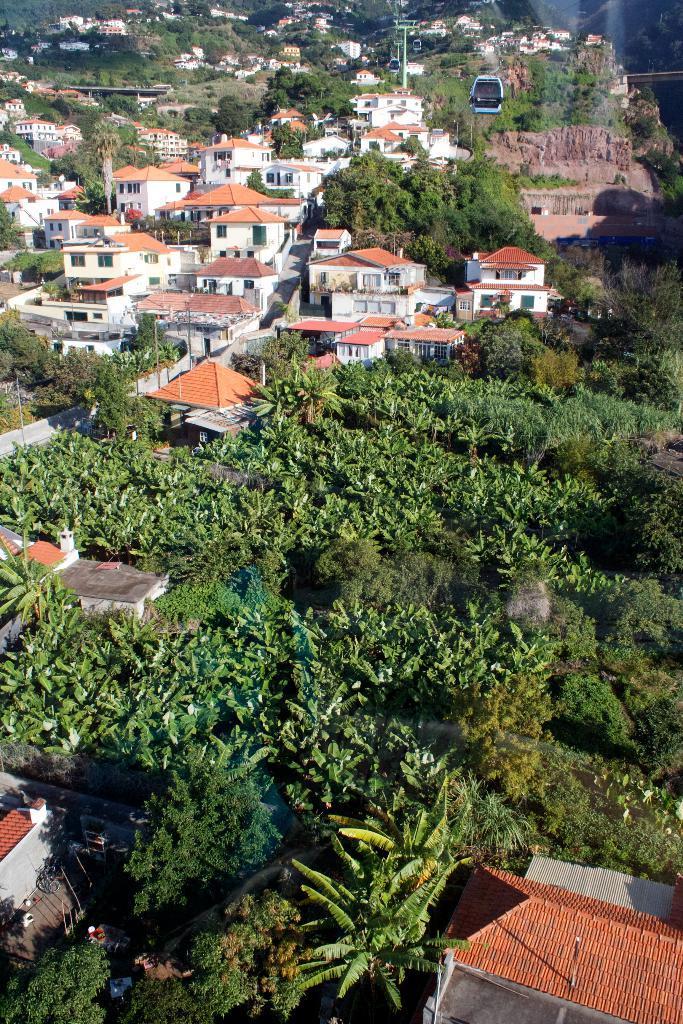Can you describe this image briefly? In this picture I can observe buildings and trees. The roofs of the buildings are in orange color. I can observe some plants on the ground in the bottom of the picture. 